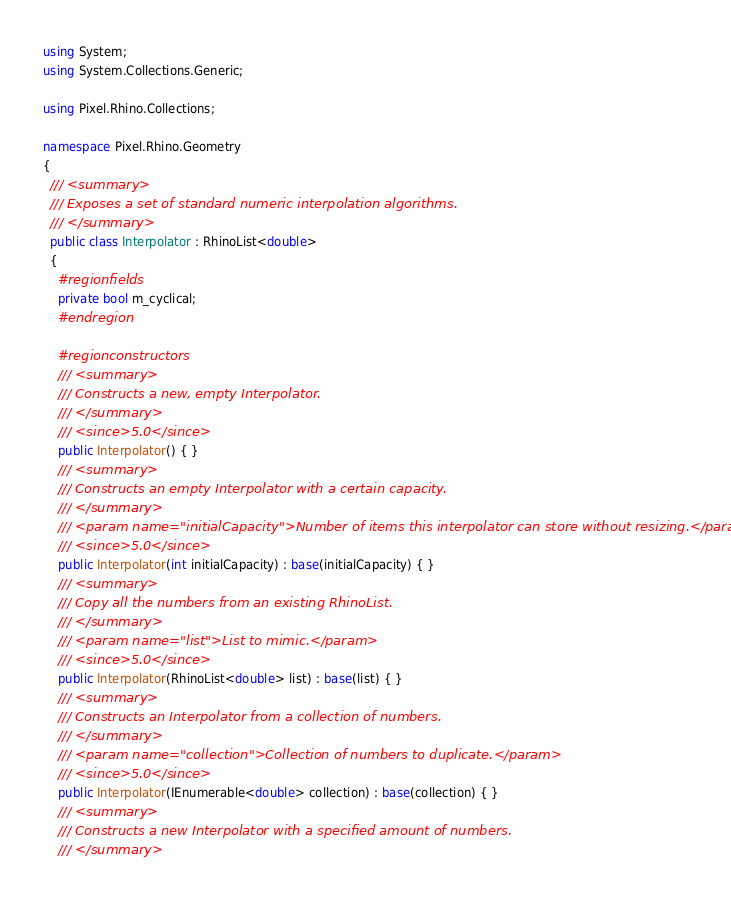<code> <loc_0><loc_0><loc_500><loc_500><_C#_>using System;
using System.Collections.Generic;

using Pixel.Rhino.Collections;

namespace Pixel.Rhino.Geometry
{
  /// <summary>
  /// Exposes a set of standard numeric interpolation algorithms.
  /// </summary>
  public class Interpolator : RhinoList<double>
  {
    #region fields
    private bool m_cyclical;
    #endregion

    #region constructors
    /// <summary>
    /// Constructs a new, empty Interpolator.
    /// </summary>
    /// <since>5.0</since>
    public Interpolator() { }
    /// <summary>
    /// Constructs an empty Interpolator with a certain capacity.
    /// </summary>
    /// <param name="initialCapacity">Number of items this interpolator can store without resizing.</param>
    /// <since>5.0</since>
    public Interpolator(int initialCapacity) : base(initialCapacity) { }
    /// <summary>
    /// Copy all the numbers from an existing RhinoList.
    /// </summary>
    /// <param name="list">List to mimic.</param>
    /// <since>5.0</since>
    public Interpolator(RhinoList<double> list) : base(list) { }
    /// <summary>
    /// Constructs an Interpolator from a collection of numbers.
    /// </summary>
    /// <param name="collection">Collection of numbers to duplicate.</param>
    /// <since>5.0</since>
    public Interpolator(IEnumerable<double> collection) : base(collection) { }
    /// <summary>
    /// Constructs a new Interpolator with a specified amount of numbers.
    /// </summary></code> 